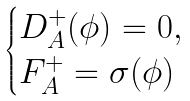<formula> <loc_0><loc_0><loc_500><loc_500>\begin{cases} D ^ { + } _ { A } ( \phi ) = 0 , \\ F ^ { + } _ { A } = \sigma ( \phi ) \end{cases}</formula> 